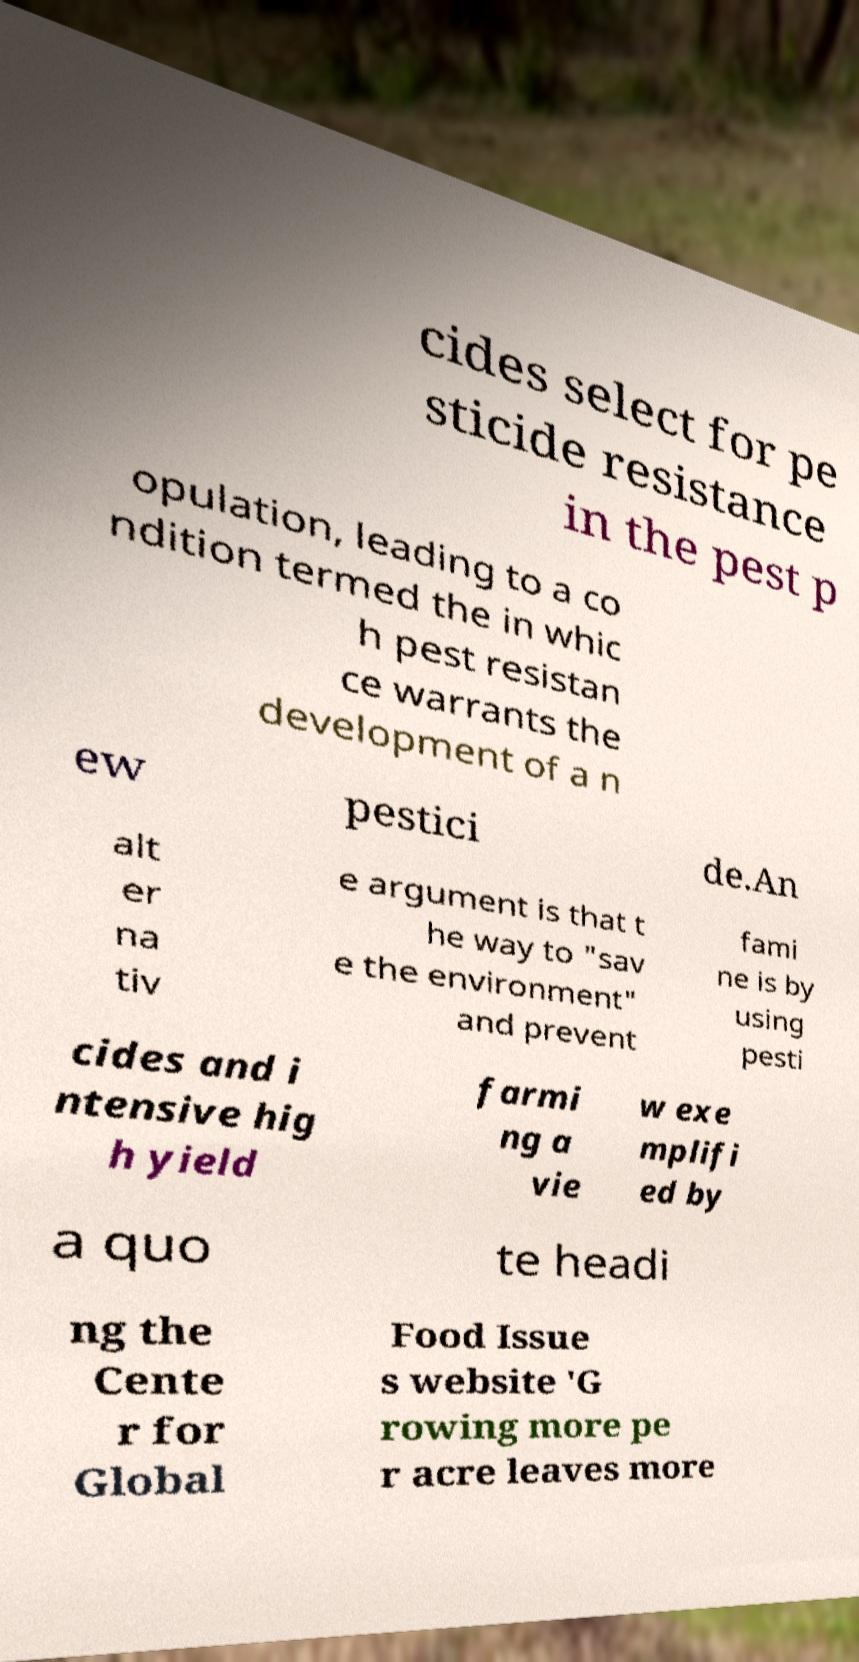Can you accurately transcribe the text from the provided image for me? cides select for pe sticide resistance in the pest p opulation, leading to a co ndition termed the in whic h pest resistan ce warrants the development of a n ew pestici de.An alt er na tiv e argument is that t he way to "sav e the environment" and prevent fami ne is by using pesti cides and i ntensive hig h yield farmi ng a vie w exe mplifi ed by a quo te headi ng the Cente r for Global Food Issue s website 'G rowing more pe r acre leaves more 